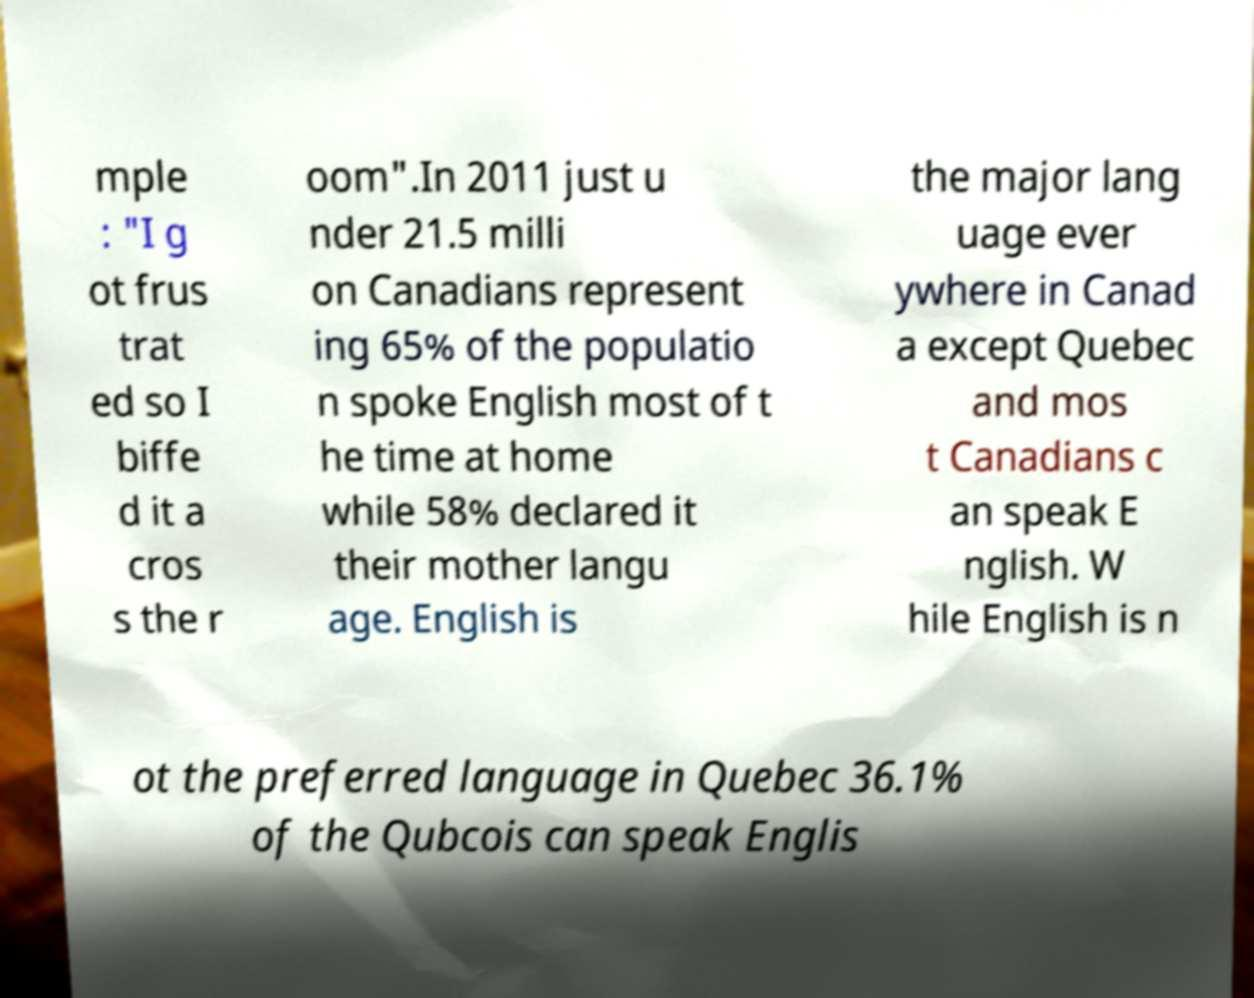There's text embedded in this image that I need extracted. Can you transcribe it verbatim? mple : "I g ot frus trat ed so I biffe d it a cros s the r oom".In 2011 just u nder 21.5 milli on Canadians represent ing 65% of the populatio n spoke English most of t he time at home while 58% declared it their mother langu age. English is the major lang uage ever ywhere in Canad a except Quebec and mos t Canadians c an speak E nglish. W hile English is n ot the preferred language in Quebec 36.1% of the Qubcois can speak Englis 